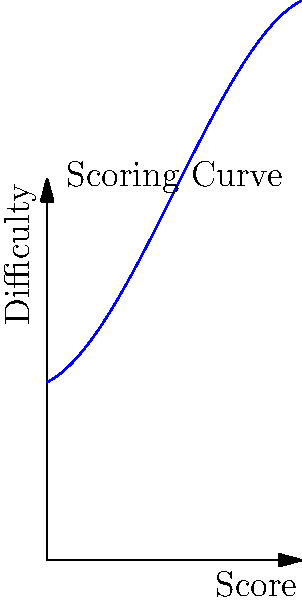In a junior gymnastics competition, the difficulty score is calculated based on the execution score using a polynomial regression model. The graph shows the relationship between the execution score (x-axis) and the difficulty score (y-axis). If you received an execution score of 8.5, what would be your approximate difficulty score according to this model? To solve this problem, we need to follow these steps:

1. Understand the graph: The blue curve represents the relationship between the execution score (x-axis) and the difficulty score (y-axis).

2. Locate the execution score: We need to find the point on the x-axis corresponding to an execution score of 8.5.

3. Find the corresponding difficulty score: From the point we located in step 2, we need to move vertically up to the curve.

4. Read the difficulty score: Once we reach the curve, we need to read the corresponding y-value.

5. Estimate the value: Since we don't have exact grid lines, we need to make an educated estimate based on the scale of the y-axis.

Looking at the graph, when x = 8.5:
- The curve is between y = 12 and y = 13
- It appears to be closer to 13 than 12
- A reasonable estimate would be approximately 12.5

Therefore, for an execution score of 8.5, the approximate difficulty score would be 12.5.
Answer: 12.5 